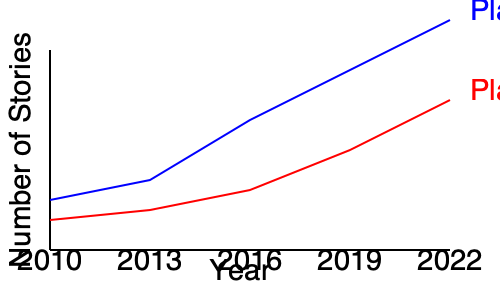Based on the line graph showing the growth of two fanfiction platforms from 2010 to 2022, which platform experienced a more rapid increase in the number of stories, and what might this suggest about the evolution of fanfiction communities? To answer this question, we need to analyze the growth patterns of both platforms:

1. Identify the platforms:
   - Blue line represents Platform A
   - Red line represents Platform B

2. Examine the slope of each line:
   - A steeper slope indicates faster growth
   - Platform A (blue) has a steeper slope than Platform B (red)

3. Compare the starting and ending points:
   - Platform A starts higher and ends much higher than Platform B
   - The gap between the two platforms widens over time

4. Analyze the growth rate:
   - Platform A shows a more consistent and rapid increase
   - Platform B shows a slower, more gradual increase

5. Interpret the data in the context of fanfiction communities:
   - Rapid growth suggests increasing popularity and user engagement
   - Platform A's faster growth might indicate:
     a) More user-friendly interface
     b) Better community features
     c) Wider range of fandoms or genres
     d) More effective marketing or word-of-mouth promotion

6. Consider the implications for contemporary storytelling:
   - The overall growth of both platforms suggests an increasing influence of fanfiction on storytelling
   - Platform A's dominance might be shaping trends in fanfiction writing and consumption

Therefore, Platform A experienced a more rapid increase in the number of stories, suggesting it may have had more success in attracting and retaining users, potentially due to superior features or community engagement strategies.
Answer: Platform A; indicates more successful user attraction and retention strategies. 